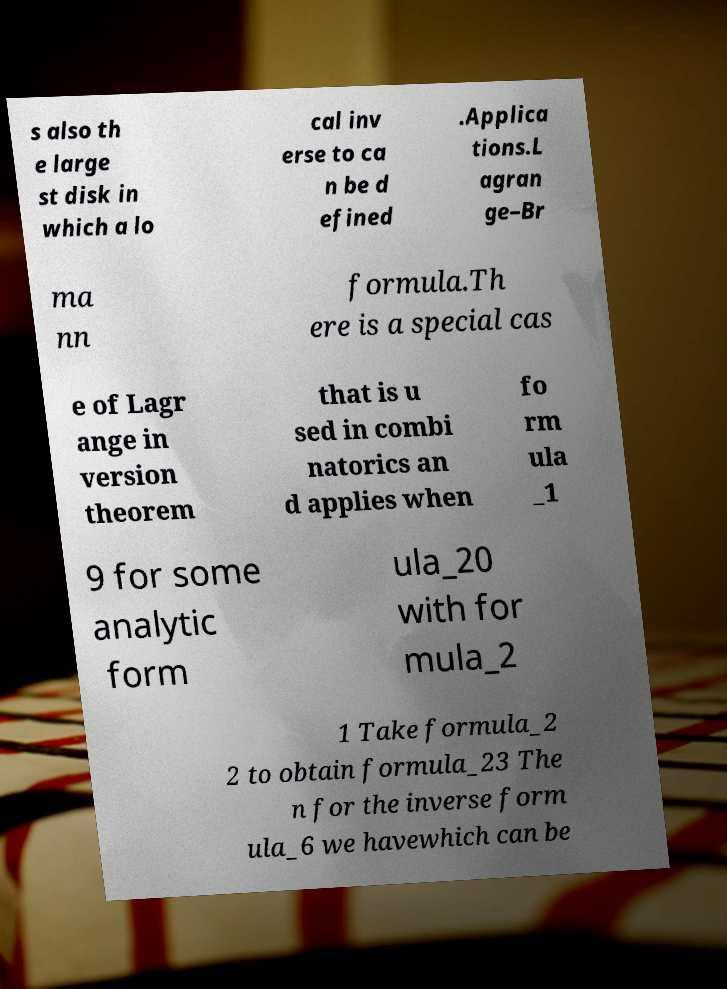Could you assist in decoding the text presented in this image and type it out clearly? s also th e large st disk in which a lo cal inv erse to ca n be d efined .Applica tions.L agran ge–Br ma nn formula.Th ere is a special cas e of Lagr ange in version theorem that is u sed in combi natorics an d applies when fo rm ula _1 9 for some analytic form ula_20 with for mula_2 1 Take formula_2 2 to obtain formula_23 The n for the inverse form ula_6 we havewhich can be 